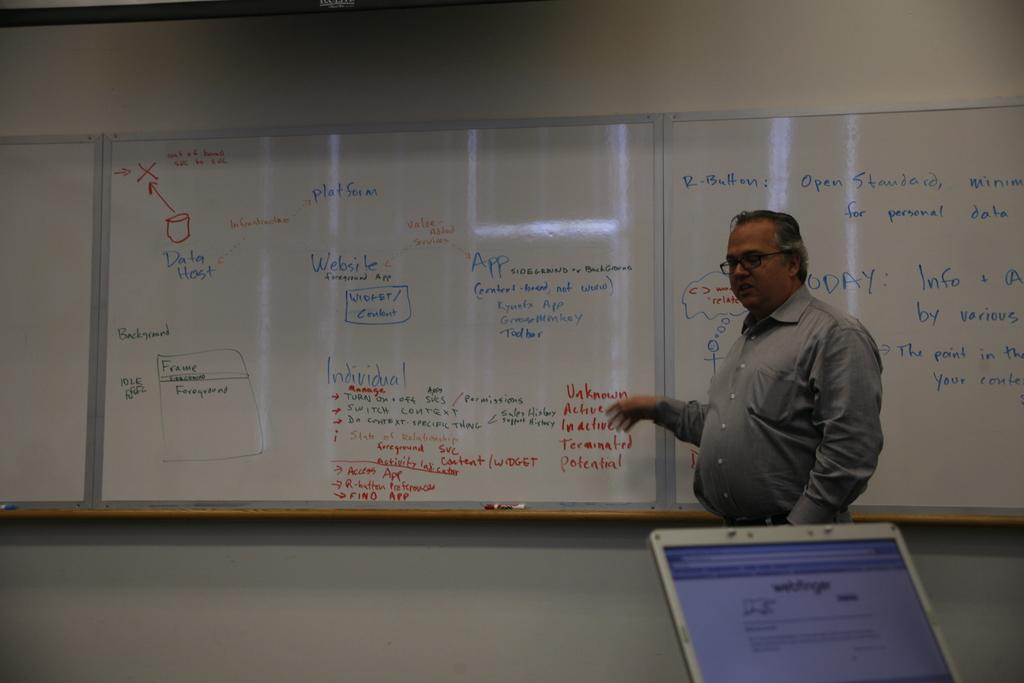<image>
Write a terse but informative summary of the picture. Teacher in front of a classroom pointing at the word "Active" on a board. 